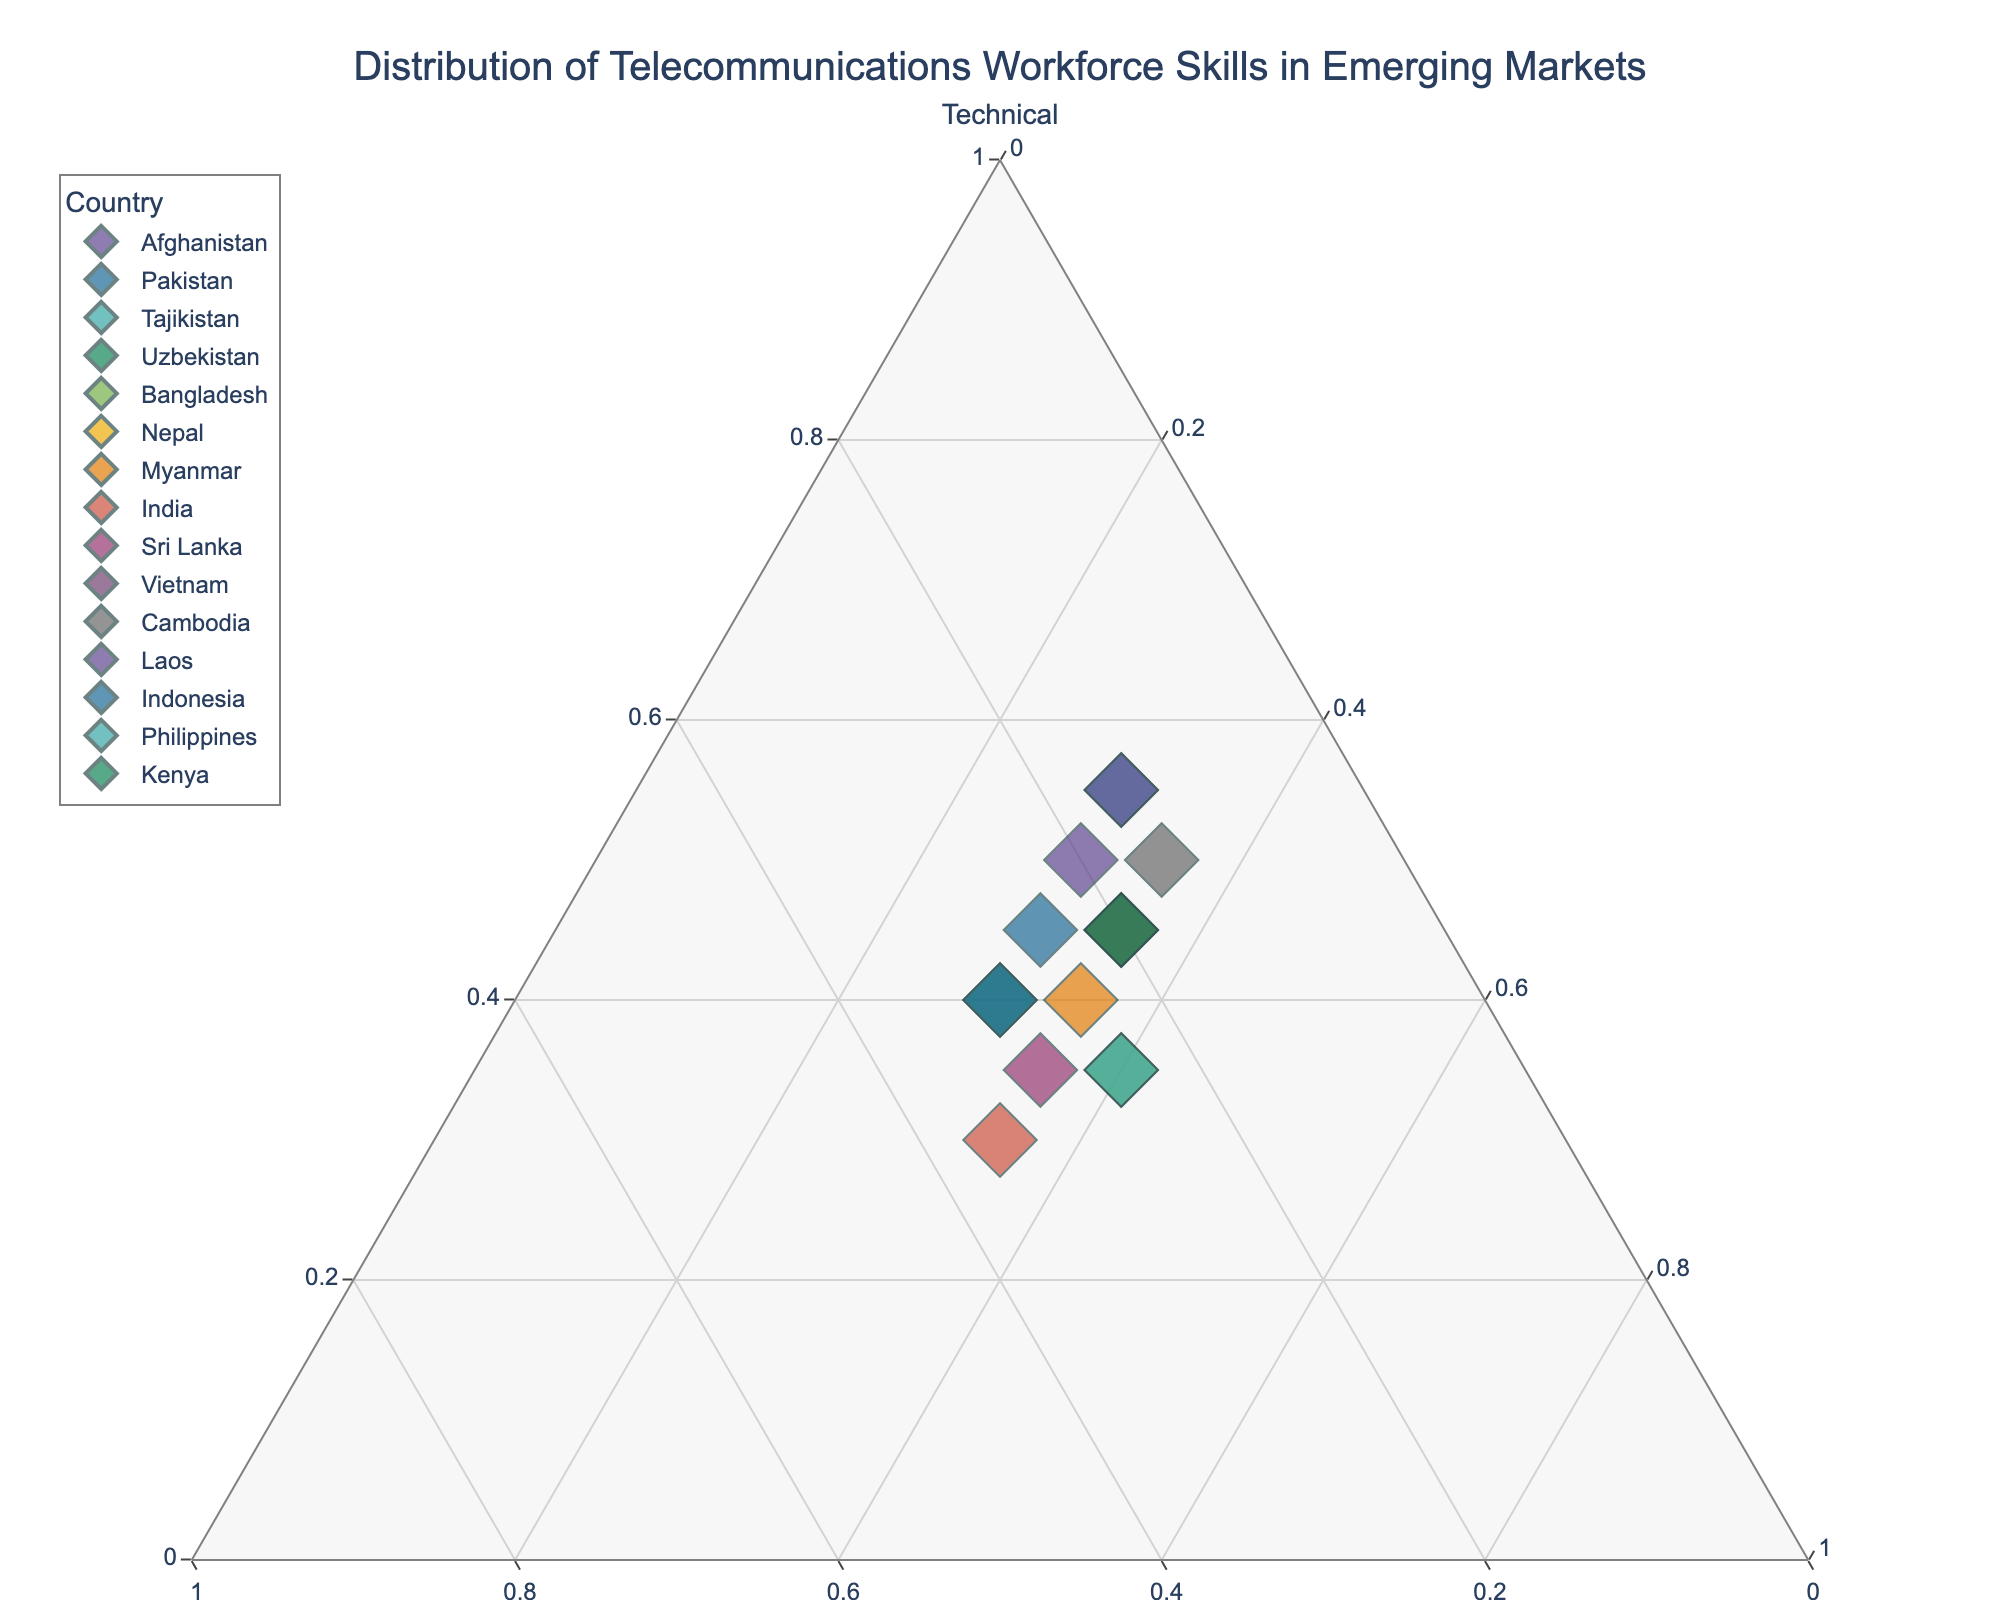What is the title of the figure? The title of the figure can be found at the top of the plot, typically centered. In this figure, it reads "Distribution of Telecommunications Workforce Skills in Emerging Markets".
Answer: Distribution of Telecommunications Workforce Skills in Emerging Markets How many countries are represented in the plot? To find the number of countries, look at the number of distinct data points or labels visible in the legend. There are 15 countries represented in the plot.
Answer: 15 Which country has the highest proportion of technical skills? Identify the data point placed the furthest along the "Technical" axis. Laos and Tajikistan both have the highest proportion of technical skills at 55%.
Answer: Laos, Tajikistan Which country has the lowest proportion of customer service skills? Locate the data point placed closest to the base of the "Customer Service" axis. Tajikistan and Laos both have the lowest proportion of customer service skills at 30%.
Answer: Tajikistan, Laos Are there any countries with an equal proportion of technical, managerial, and customer service skills? Search for a data point located near the center of the ternary plot. None of the countries have an equal proportion, as all points are offset from the center.
Answer: No Which countries have a higher proportion of managerial skills compared to technical skills? Compare the relative positions of each data point along the "Managerial" and "Technical" axes. India has a higher proportion of managerial skills (35%) compared to technical skills (30%).
Answer: India What is the average proportion of customer service skills among all countries? Calculate the average customer service proportion by summing up all customer service values and dividing by the number of countries: (30+30+30+30+40+35+35+35+35+30+35+30+30+40+35)/15 = 33%.
Answer: 33% Compare Afghanistan’s and Bangladesh’s workforce distribution; which country has a higher proportion of managerial skills? Look at the coordinates for Afghanistan and Bangladesh along the "Managerial" axis. Afghanistan has 20% and Bangladesh has 25%.
Answer: Bangladesh Which country has the same proportion of customer service skills as Afghanistan? Look for countries with a similar placement on the "Customer Service" axis as Afghanistan (30%). Pakistan, Tajikistan, Uzbekistan, and Laos all have 30% customer service skills.
Answer: Pakistan, Tajikistan, Uzbekistan, Laos Is there a correlation between the proportion of technical skills and customer service skills? Observe the positions and patterns of the data points along the "Technical" and "Customer Service" axes. Visual inspection shows there is no clear linear correlation between the two skills.
Answer: No 